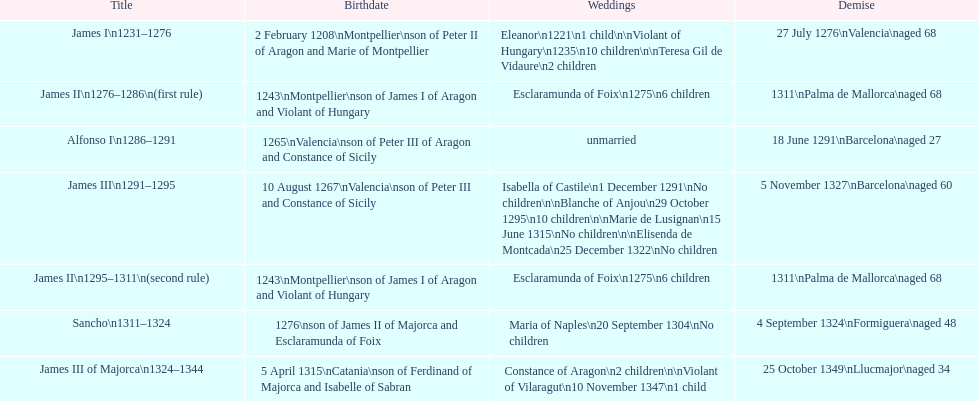Who came to power after the rule of james iii? James II. 